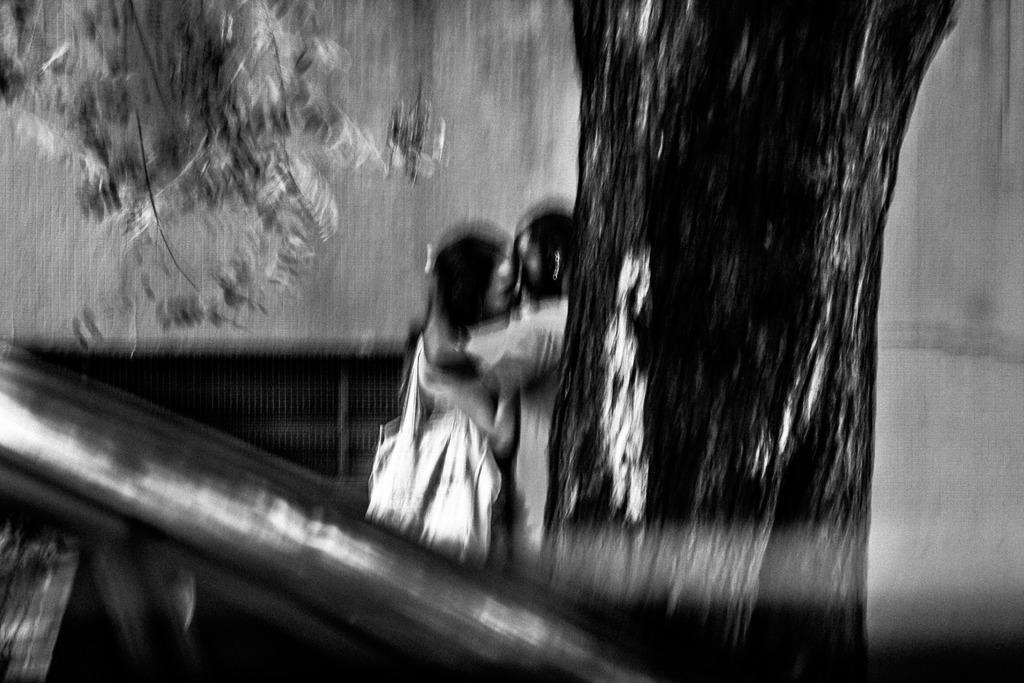How would you summarize this image in a sentence or two? It looks like a black and white picture. We can see there are two people standing on the path and on the right side of the people there is a tree and behind the people there is a wall and in front of the people it is looking like a vehicle. 